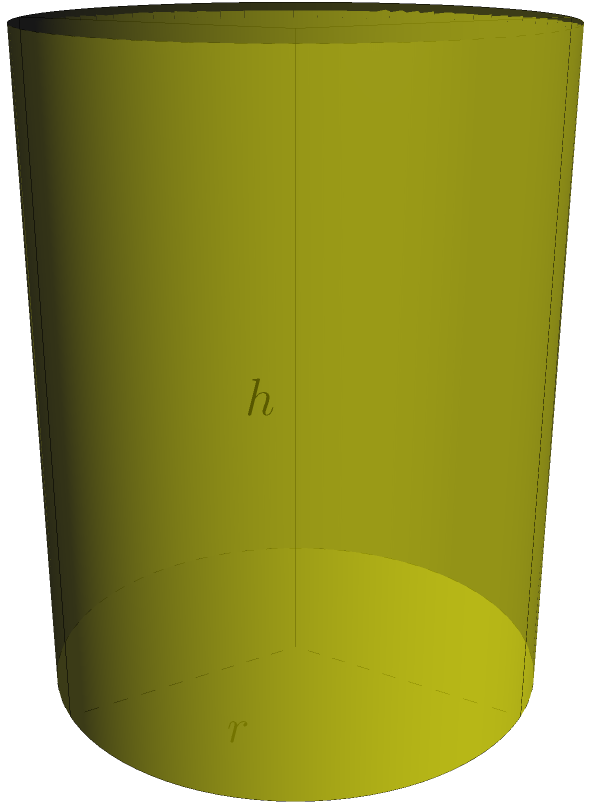A local fruit stand in Costa Rica uses a pineapple-shaped container to store freshly squeezed pineapple juice. The container has a height of 20 cm and a maximum radius of 8 cm. Assuming the container is a perfect solid of revolution, what is the volume of juice it can hold in liters? (Round your answer to the nearest tenth of a liter) To solve this problem, we'll follow these steps:

1) The shape of the container is a solid of revolution, which can be approximated by a cylinder.

2) The volume of a cylinder is given by the formula:
   $$V = \pi r^2 h$$
   where $r$ is the radius and $h$ is the height.

3) We're given:
   $r = 8$ cm
   $h = 20$ cm

4) Let's substitute these values into the formula:
   $$V = \pi (8 \text{ cm})^2 (20 \text{ cm})$$

5) Calculate:
   $$V = \pi (64 \text{ cm}^2) (20 \text{ cm}) = 1280\pi \text{ cm}^3$$

6) Calculate the value of $\pi$ (to 4 decimal places):
   $$V = 1280 * 3.1416 = 4021.2480 \text{ cm}^3$$

7) Convert cubic centimeters to liters:
   1 liter = 1000 cm³
   $$4021.2480 \text{ cm}^3 = 4.0212480 \text{ liters}$$

8) Rounding to the nearest tenth of a liter:
   $$4.0 \text{ liters}$$

Therefore, the pineapple-shaped container can hold approximately 4.0 liters of juice.
Answer: 4.0 liters 